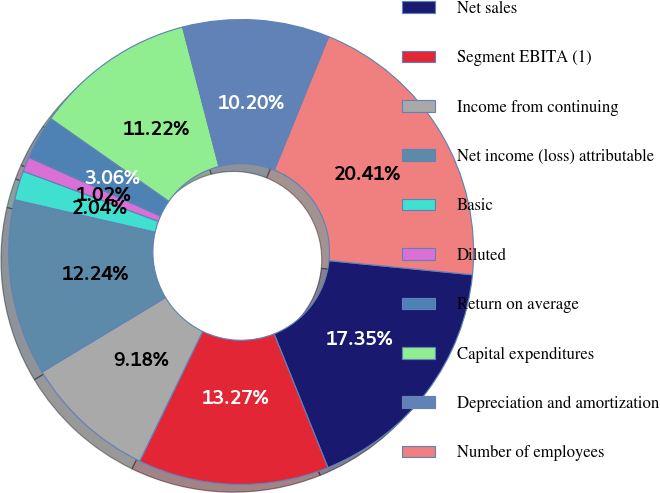Convert chart. <chart><loc_0><loc_0><loc_500><loc_500><pie_chart><fcel>Net sales<fcel>Segment EBITA (1)<fcel>Income from continuing<fcel>Net income (loss) attributable<fcel>Basic<fcel>Diluted<fcel>Return on average<fcel>Capital expenditures<fcel>Depreciation and amortization<fcel>Number of employees<nl><fcel>17.35%<fcel>13.27%<fcel>9.18%<fcel>12.24%<fcel>2.04%<fcel>1.02%<fcel>3.06%<fcel>11.22%<fcel>10.2%<fcel>20.41%<nl></chart> 